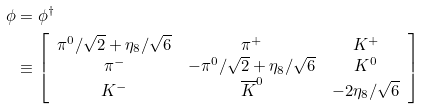Convert formula to latex. <formula><loc_0><loc_0><loc_500><loc_500>\phi & = \phi ^ { \dagger } \\ & \equiv \left [ \begin{array} { c c c } \pi ^ { 0 } / \sqrt { 2 } + \eta _ { 8 } / \sqrt { 6 } & \pi ^ { + } & K ^ { + } \\ \pi ^ { - } & - \pi ^ { 0 } / \sqrt { 2 } + \eta _ { 8 } / \sqrt { 6 } & K ^ { 0 } \\ K ^ { - } & \overline { K } ^ { 0 } & - 2 \eta _ { 8 } / \sqrt { 6 } \end{array} \right ]</formula> 